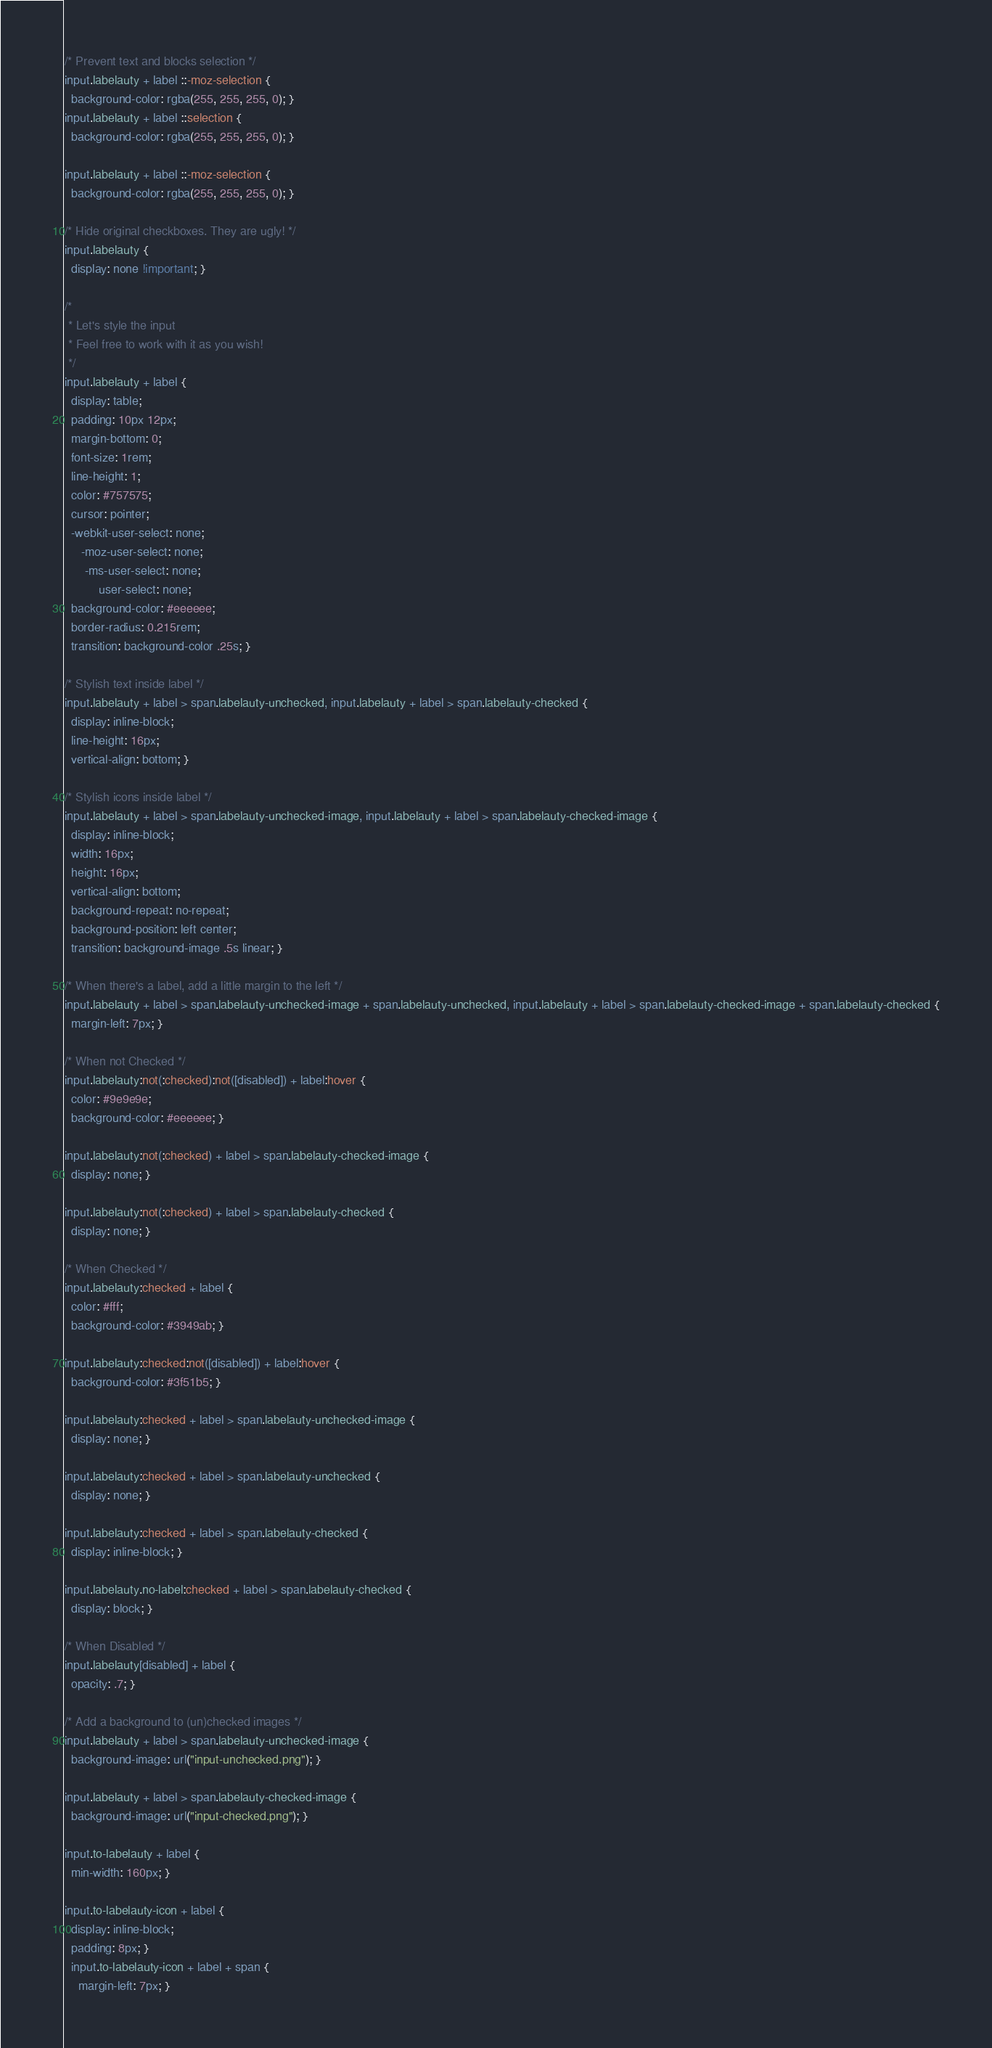<code> <loc_0><loc_0><loc_500><loc_500><_CSS_>/* Prevent text and blocks selection */
input.labelauty + label ::-moz-selection {
  background-color: rgba(255, 255, 255, 0); }
input.labelauty + label ::selection {
  background-color: rgba(255, 255, 255, 0); }

input.labelauty + label ::-moz-selection {
  background-color: rgba(255, 255, 255, 0); }

/* Hide original checkboxes. They are ugly! */
input.labelauty {
  display: none !important; }

/*
 * Let's style the input
 * Feel free to work with it as you wish!
 */
input.labelauty + label {
  display: table;
  padding: 10px 12px;
  margin-bottom: 0;
  font-size: 1rem;
  line-height: 1;
  color: #757575;
  cursor: pointer;
  -webkit-user-select: none;
     -moz-user-select: none;
      -ms-user-select: none;
          user-select: none;
  background-color: #eeeeee;
  border-radius: 0.215rem;
  transition: background-color .25s; }

/* Stylish text inside label */
input.labelauty + label > span.labelauty-unchecked, input.labelauty + label > span.labelauty-checked {
  display: inline-block;
  line-height: 16px;
  vertical-align: bottom; }

/* Stylish icons inside label */
input.labelauty + label > span.labelauty-unchecked-image, input.labelauty + label > span.labelauty-checked-image {
  display: inline-block;
  width: 16px;
  height: 16px;
  vertical-align: bottom;
  background-repeat: no-repeat;
  background-position: left center;
  transition: background-image .5s linear; }

/* When there's a label, add a little margin to the left */
input.labelauty + label > span.labelauty-unchecked-image + span.labelauty-unchecked, input.labelauty + label > span.labelauty-checked-image + span.labelauty-checked {
  margin-left: 7px; }

/* When not Checked */
input.labelauty:not(:checked):not([disabled]) + label:hover {
  color: #9e9e9e;
  background-color: #eeeeee; }

input.labelauty:not(:checked) + label > span.labelauty-checked-image {
  display: none; }

input.labelauty:not(:checked) + label > span.labelauty-checked {
  display: none; }

/* When Checked */
input.labelauty:checked + label {
  color: #fff;
  background-color: #3949ab; }

input.labelauty:checked:not([disabled]) + label:hover {
  background-color: #3f51b5; }

input.labelauty:checked + label > span.labelauty-unchecked-image {
  display: none; }

input.labelauty:checked + label > span.labelauty-unchecked {
  display: none; }

input.labelauty:checked + label > span.labelauty-checked {
  display: inline-block; }

input.labelauty.no-label:checked + label > span.labelauty-checked {
  display: block; }

/* When Disabled */
input.labelauty[disabled] + label {
  opacity: .7; }

/* Add a background to (un)checked images */
input.labelauty + label > span.labelauty-unchecked-image {
  background-image: url("input-unchecked.png"); }

input.labelauty + label > span.labelauty-checked-image {
  background-image: url("input-checked.png"); }

input.to-labelauty + label {
  min-width: 160px; }

input.to-labelauty-icon + label {
  display: inline-block;
  padding: 8px; }
  input.to-labelauty-icon + label + span {
    margin-left: 7px; }
</code> 